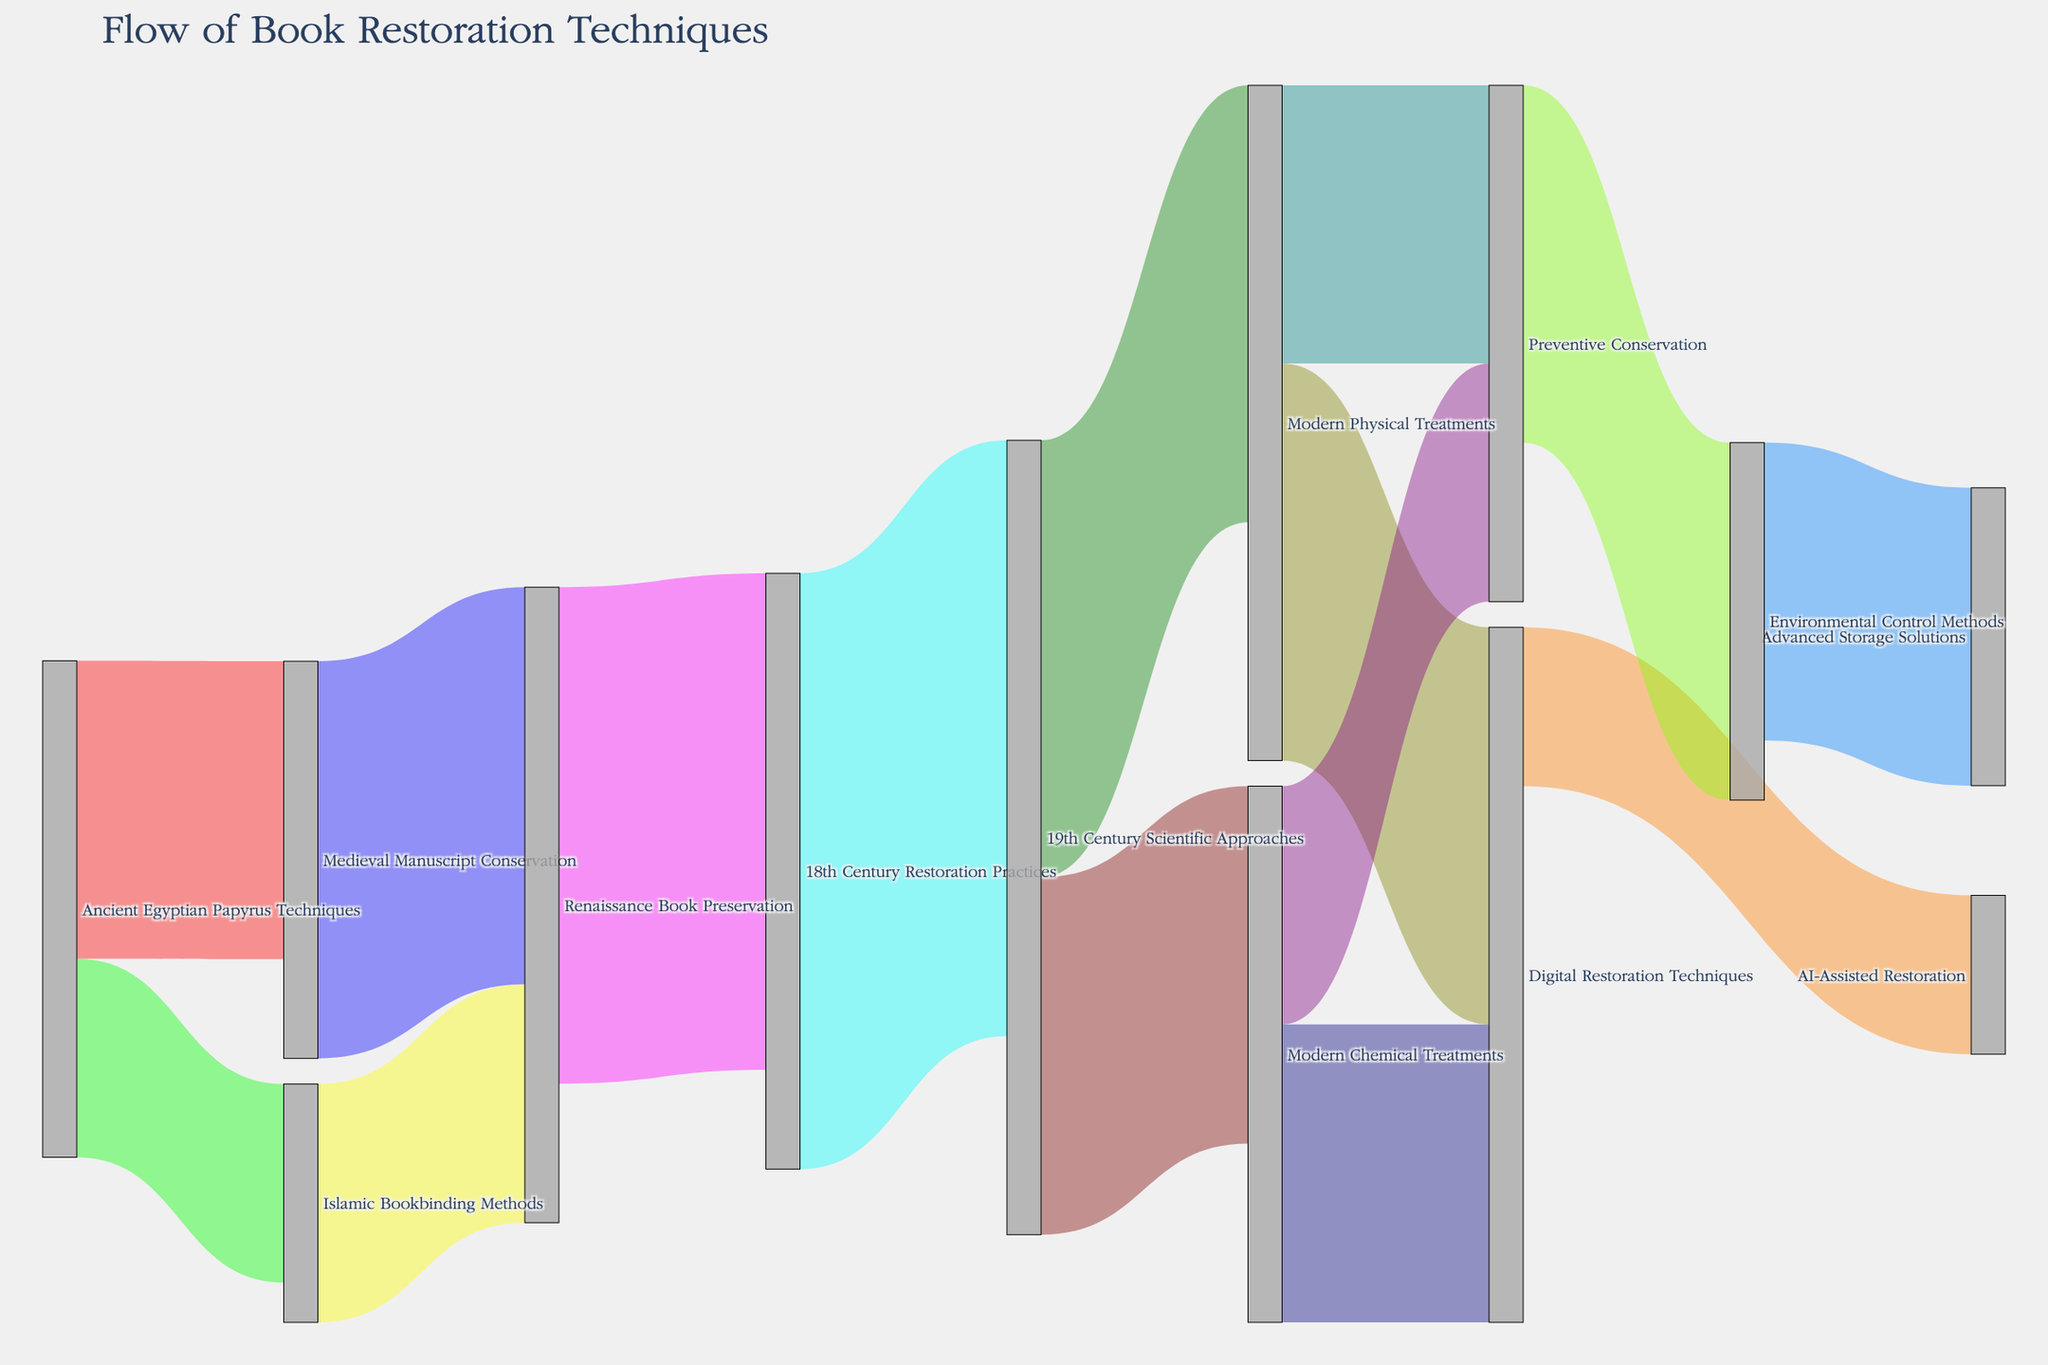What is the title of the Sankey Diagram? The title of a plot is usually found at the top of the figure. It provides a quick summary of what the diagram is about. For this Sankey Diagram, the title "Flow of Book Restoration Techniques" indicates it illustrates how book restoration methods have evolved across different historical periods.
Answer: Flow of Book Restoration Techniques What are the two modern techniques that derive from 19th Century Scientific Approaches? To answer this, we need to trace the links starting from the 19th Century Scientific Approaches node and look for the connections leading to modern techniques. From the diagram, we see two outgoing flows from the 19th Century Scientific Approaches leading to Modern Chemical Treatments and Modern Physical Treatments.
Answer: Modern Chemical Treatments, Modern Physical Treatments How many techniques have connections to Renaissance Book Preservation? We should count the number of flows connected to the Renaissance Book Preservation node, both incoming and outgoing. The diagram shows four connections in total: two inflows from Medieval Manuscript Conservation and Islamic Bookbinding Methods, and two outflows to 18th Century Restoration Practices.
Answer: Four Which technique has the highest flow value, and what is that value? We need to look for the link with the highest numerical value. The value next to each link indicates the flow magnitude. The highest value is from 18th Century Restoration Practices to 19th Century Scientific Approaches at 30.
Answer: 18th Century Restoration Practices to 19th Century Scientific Approaches, 30 Which technique is the final node in the longest chain of restoration methods? To identify the final node in the longest chain, we should follow the longest sequence of connections starting from an ancient technique to a modern one. Tracing through the diagram: Ancient Egyptian Papyrus Techniques → Medieval Manuscript Conservation → Renaissance Book Preservation → 18th Century Restoration Practices → 19th Century Scientific Approaches → Modern Physical Treatments → Digital Restoration Techniques → AI-Assisted Restoration. The final node in this chain is AI-Assisted Restoration.
Answer: AI-Assisted Restoration What is the combined outflow value from Digital Restoration Techniques? To find the combined outflow value, sum the values of all outgoing links from Digital Restoration Techniques. The diagram shows two outflows: one to AI-Assisted Restoration (value of 8) and one to Preventive Conservation (value of 20). Adding these gives a combined value of 28.
Answer: 28 Is Preventive Conservation more influenced by Modern Chemical Treatments or Modern Physical Treatments? We compare the values of the links directed to Preventive Conservation from both Modern Chemical Treatments and Modern Physical Treatments. The values are 12 (from Modern Chemical Treatments) and 14 (from Modern Physical Treatments). Modern Physical Treatments has the higher influence.
Answer: Modern Physical Treatments What is the combined influence of Islamic Bookbinding Methods and Medieval Manuscript Conservation on Renaissance Book Preservation? To calculate this, we sum the values of the inflows to Renaissance Book Preservation from both Islamic Bookbinding Methods and Medieval Manuscript Conservation. These values are 12 and 20, respectively. The combined influence is 12 + 20 = 32.
Answer: 32 What is the total number of different restoration techniques shown in the diagram? The total number of unique nodes (techniques) in the diagram can be counted. Nodes include all unique items in the source and target columns. Counting these, we have: Ancient Egyptian Papyrus Techniques, Medieval Manuscript Conservation, Islamic Bookbinding Methods, Renaissance Book Preservation, 18th Century Restoration Practices, 19th Century Scientific Approaches, Modern Chemical Treatments, Modern Physical Treatments, Digital Restoration Techniques, AI-Assisted Restoration, Preventive Conservation, Environmental Control Methods, and Advanced Storage Solutions. There are 13 unique techniques.
Answer: 13 Which two techniques both contribute to Digital Restoration Techniques and Preventive Conservation? We look for nodes with outflows to both Digital Restoration Techniques and Preventive Conservation. Modern Chemical Treatments and Modern Physical Treatments are such nodes, as they both have links leading to Digital Restoration Techniques and Preventive Conservation.
Answer: Modern Chemical Treatments, Modern Physical Treatments 